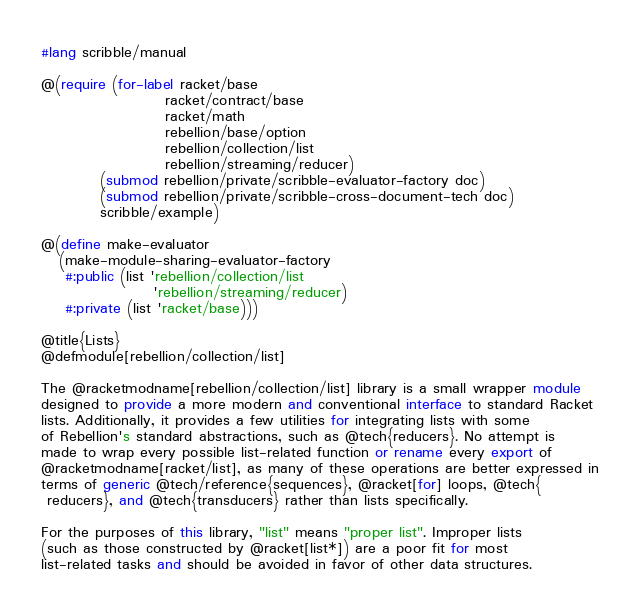Convert code to text. <code><loc_0><loc_0><loc_500><loc_500><_Racket_>#lang scribble/manual

@(require (for-label racket/base
                     racket/contract/base
                     racket/math
                     rebellion/base/option
                     rebellion/collection/list
                     rebellion/streaming/reducer)
          (submod rebellion/private/scribble-evaluator-factory doc)
          (submod rebellion/private/scribble-cross-document-tech doc)
          scribble/example)

@(define make-evaluator
   (make-module-sharing-evaluator-factory
    #:public (list 'rebellion/collection/list
                   'rebellion/streaming/reducer)
    #:private (list 'racket/base)))

@title{Lists}
@defmodule[rebellion/collection/list]

The @racketmodname[rebellion/collection/list] library is a small wrapper module
designed to provide a more modern and conventional interface to standard Racket
lists. Additionally, it provides a few utilities for integrating lists with some
of Rebellion's standard abstractions, such as @tech{reducers}. No attempt is
made to wrap every possible list-related function or rename every export of
@racketmodname[racket/list], as many of these operations are better expressed in
terms of generic @tech/reference{sequences}, @racket[for] loops, @tech{
 reducers}, and @tech{transducers} rather than lists specifically.

For the purposes of this library, "list" means "proper list". Improper lists
(such as those constructed by @racket[list*]) are a poor fit for most
list-related tasks and should be avoided in favor of other data structures.
</code> 